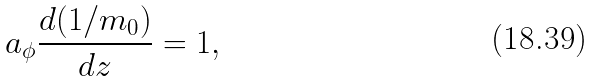Convert formula to latex. <formula><loc_0><loc_0><loc_500><loc_500>a _ { \phi } \frac { d ( 1 / m _ { 0 } ) } { d z } = 1 ,</formula> 